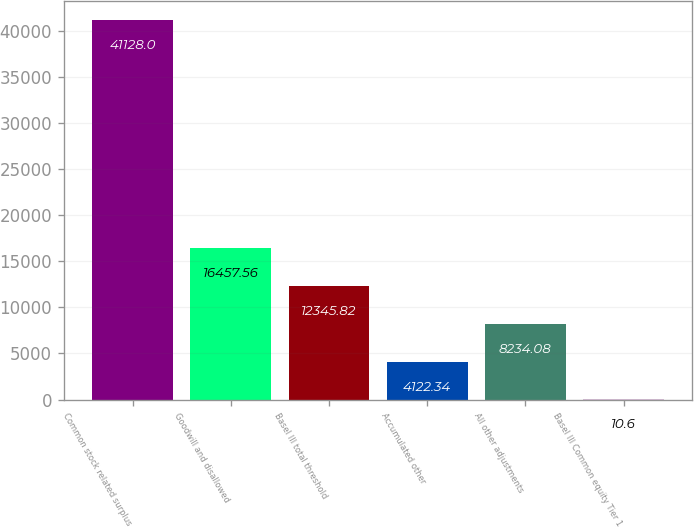<chart> <loc_0><loc_0><loc_500><loc_500><bar_chart><fcel>Common stock related surplus<fcel>Goodwill and disallowed<fcel>Basel III total threshold<fcel>Accumulated other<fcel>All other adjustments<fcel>Basel III Common equity Tier 1<nl><fcel>41128<fcel>16457.6<fcel>12345.8<fcel>4122.34<fcel>8234.08<fcel>10.6<nl></chart> 